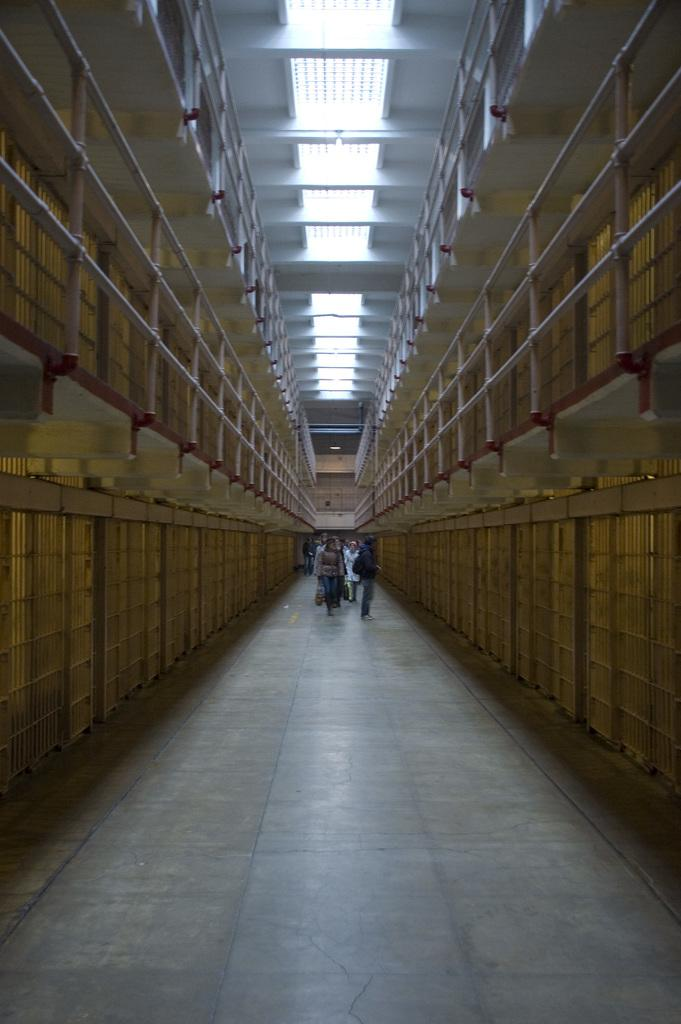What are the people in the image doing? The people in the image are walking. On what surface are the people walking? The people are walking on the floor. What feature surrounds the floor in the image? There are railings around the floor. What can be seen on the roof in the image? There are lights on the roof. What type of observation can be made about the nation in the image? There is no reference to a nation in the image, so it's not possible to make any observations about it. Is there a gun visible in the image? There is no gun present in the image. 